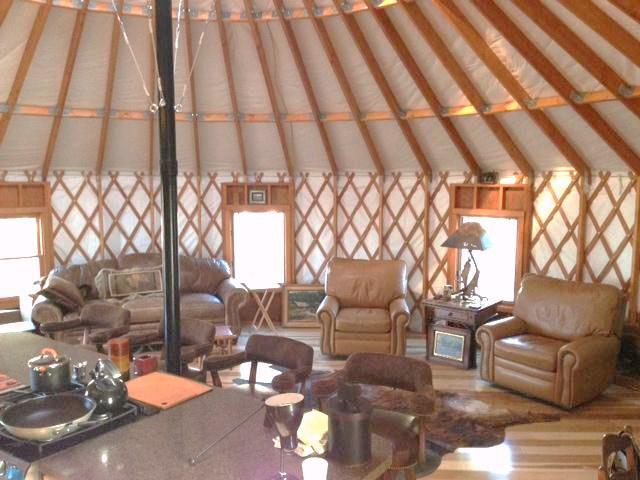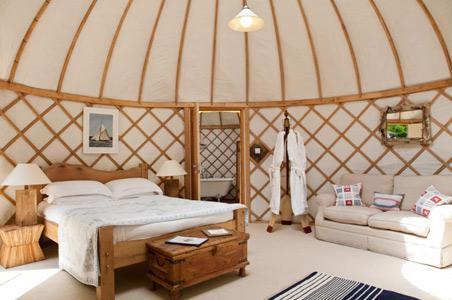The first image is the image on the left, the second image is the image on the right. Evaluate the accuracy of this statement regarding the images: "One of the images is of a bedroom.". Is it true? Answer yes or no. Yes. The first image is the image on the left, the second image is the image on the right. Assess this claim about the two images: "A ladder with rungs leads up to a loft area in at least one image.". Correct or not? Answer yes or no. No. The first image is the image on the left, the second image is the image on the right. Considering the images on both sides, is "A ladder goes up to an upper area of the hut in one of the images." valid? Answer yes or no. No. 